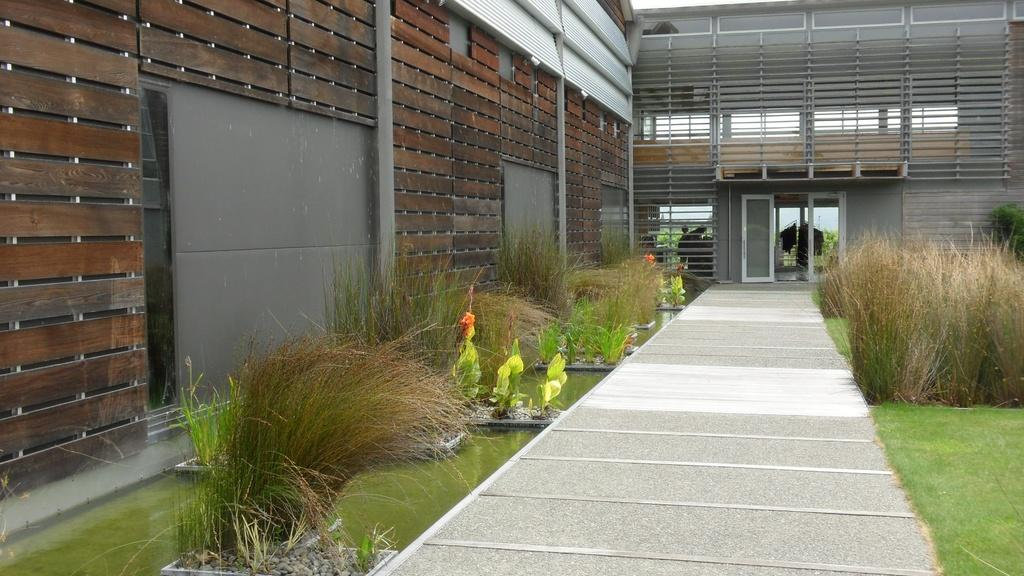What natural element can be seen in the image? Water is visible in the image. What type of vegetation is present in the image? There are plants and grass visible in the image. What architectural feature can be seen in the image? There is a door in the image. What type of structure is present in the image? There is a building in the image. What type of prison can be seen in the image? There is no prison present in the image. How many jellyfish are swimming in the water in the image? There are no jellyfish present in the image. What type of bread is being used to make a sandwich in the image? There is no bread or sandwich present in the image. 